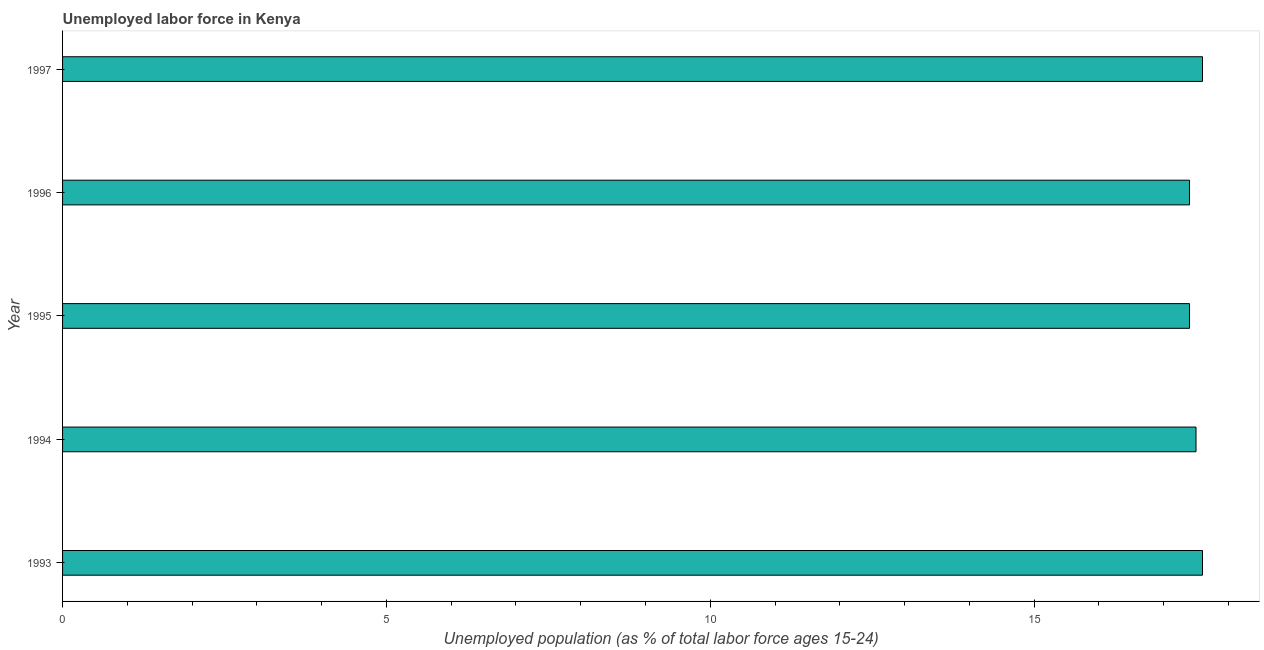Does the graph contain grids?
Provide a succinct answer. No. What is the title of the graph?
Your answer should be compact. Unemployed labor force in Kenya. What is the label or title of the X-axis?
Your response must be concise. Unemployed population (as % of total labor force ages 15-24). What is the total unemployed youth population in 1997?
Give a very brief answer. 17.6. Across all years, what is the maximum total unemployed youth population?
Your response must be concise. 17.6. Across all years, what is the minimum total unemployed youth population?
Give a very brief answer. 17.4. What is the sum of the total unemployed youth population?
Provide a short and direct response. 87.5. What is the difference between the total unemployed youth population in 1995 and 1997?
Give a very brief answer. -0.2. What is the average total unemployed youth population per year?
Offer a terse response. 17.5. What is the median total unemployed youth population?
Make the answer very short. 17.5. In how many years, is the total unemployed youth population greater than 13 %?
Offer a terse response. 5. Is the total unemployed youth population in 1993 less than that in 1997?
Ensure brevity in your answer.  No. What is the difference between the highest and the second highest total unemployed youth population?
Your response must be concise. 0. In how many years, is the total unemployed youth population greater than the average total unemployed youth population taken over all years?
Your answer should be very brief. 2. How many bars are there?
Your response must be concise. 5. Are all the bars in the graph horizontal?
Keep it short and to the point. Yes. How many years are there in the graph?
Your answer should be very brief. 5. Are the values on the major ticks of X-axis written in scientific E-notation?
Keep it short and to the point. No. What is the Unemployed population (as % of total labor force ages 15-24) of 1993?
Your answer should be compact. 17.6. What is the Unemployed population (as % of total labor force ages 15-24) in 1994?
Offer a terse response. 17.5. What is the Unemployed population (as % of total labor force ages 15-24) in 1995?
Keep it short and to the point. 17.4. What is the Unemployed population (as % of total labor force ages 15-24) in 1996?
Give a very brief answer. 17.4. What is the Unemployed population (as % of total labor force ages 15-24) in 1997?
Offer a very short reply. 17.6. What is the difference between the Unemployed population (as % of total labor force ages 15-24) in 1993 and 1996?
Your answer should be compact. 0.2. What is the difference between the Unemployed population (as % of total labor force ages 15-24) in 1993 and 1997?
Offer a terse response. 0. What is the difference between the Unemployed population (as % of total labor force ages 15-24) in 1994 and 1995?
Offer a terse response. 0.1. What is the difference between the Unemployed population (as % of total labor force ages 15-24) in 1994 and 1997?
Your answer should be compact. -0.1. What is the difference between the Unemployed population (as % of total labor force ages 15-24) in 1995 and 1997?
Give a very brief answer. -0.2. What is the ratio of the Unemployed population (as % of total labor force ages 15-24) in 1993 to that in 1994?
Make the answer very short. 1.01. What is the ratio of the Unemployed population (as % of total labor force ages 15-24) in 1993 to that in 1995?
Your answer should be very brief. 1.01. What is the ratio of the Unemployed population (as % of total labor force ages 15-24) in 1993 to that in 1996?
Ensure brevity in your answer.  1.01. What is the ratio of the Unemployed population (as % of total labor force ages 15-24) in 1994 to that in 1996?
Make the answer very short. 1.01. What is the ratio of the Unemployed population (as % of total labor force ages 15-24) in 1996 to that in 1997?
Make the answer very short. 0.99. 